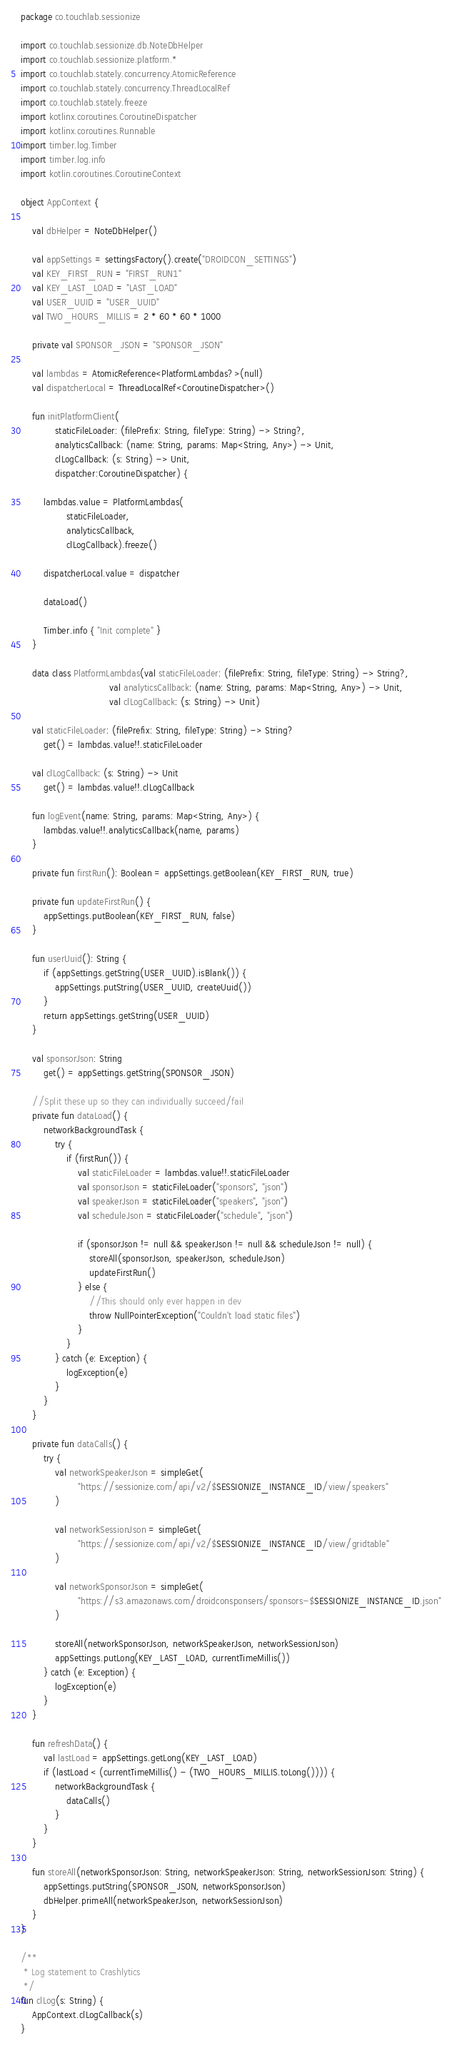Convert code to text. <code><loc_0><loc_0><loc_500><loc_500><_Kotlin_>package co.touchlab.sessionize

import co.touchlab.sessionize.db.NoteDbHelper
import co.touchlab.sessionize.platform.*
import co.touchlab.stately.concurrency.AtomicReference
import co.touchlab.stately.concurrency.ThreadLocalRef
import co.touchlab.stately.freeze
import kotlinx.coroutines.CoroutineDispatcher
import kotlinx.coroutines.Runnable
import timber.log.Timber
import timber.log.info
import kotlin.coroutines.CoroutineContext

object AppContext {

    val dbHelper = NoteDbHelper()

    val appSettings = settingsFactory().create("DROIDCON_SETTINGS")
    val KEY_FIRST_RUN = "FIRST_RUN1"
    val KEY_LAST_LOAD = "LAST_LOAD"
    val USER_UUID = "USER_UUID"
    val TWO_HOURS_MILLIS = 2 * 60 * 60 * 1000

    private val SPONSOR_JSON = "SPONSOR_JSON"

    val lambdas = AtomicReference<PlatformLambdas?>(null)
    val dispatcherLocal = ThreadLocalRef<CoroutineDispatcher>()

    fun initPlatformClient(
            staticFileLoader: (filePrefix: String, fileType: String) -> String?,
            analyticsCallback: (name: String, params: Map<String, Any>) -> Unit,
            clLogCallback: (s: String) -> Unit,
            dispatcher:CoroutineDispatcher) {

        lambdas.value = PlatformLambdas(
                staticFileLoader,
                analyticsCallback,
                clLogCallback).freeze()

        dispatcherLocal.value = dispatcher

        dataLoad()

        Timber.info { "Init complete" }
    }

    data class PlatformLambdas(val staticFileLoader: (filePrefix: String, fileType: String) -> String?,
                               val analyticsCallback: (name: String, params: Map<String, Any>) -> Unit,
                               val clLogCallback: (s: String) -> Unit)

    val staticFileLoader: (filePrefix: String, fileType: String) -> String?
        get() = lambdas.value!!.staticFileLoader

    val clLogCallback: (s: String) -> Unit
        get() = lambdas.value!!.clLogCallback

    fun logEvent(name: String, params: Map<String, Any>) {
        lambdas.value!!.analyticsCallback(name, params)
    }

    private fun firstRun(): Boolean = appSettings.getBoolean(KEY_FIRST_RUN, true)

    private fun updateFirstRun() {
        appSettings.putBoolean(KEY_FIRST_RUN, false)
    }

    fun userUuid(): String {
        if (appSettings.getString(USER_UUID).isBlank()) {
            appSettings.putString(USER_UUID, createUuid())
        }
        return appSettings.getString(USER_UUID)
    }

    val sponsorJson: String
        get() = appSettings.getString(SPONSOR_JSON)

    //Split these up so they can individually succeed/fail
    private fun dataLoad() {
        networkBackgroundTask {
            try {
                if (firstRun()) {
                    val staticFileLoader = lambdas.value!!.staticFileLoader
                    val sponsorJson = staticFileLoader("sponsors", "json")
                    val speakerJson = staticFileLoader("speakers", "json")
                    val scheduleJson = staticFileLoader("schedule", "json")

                    if (sponsorJson != null && speakerJson != null && scheduleJson != null) {
                        storeAll(sponsorJson, speakerJson, scheduleJson)
                        updateFirstRun()
                    } else {
                        //This should only ever happen in dev
                        throw NullPointerException("Couldn't load static files")
                    }
                }
            } catch (e: Exception) {
                logException(e)
            }
        }
    }

    private fun dataCalls() {
        try {
            val networkSpeakerJson = simpleGet(
                    "https://sessionize.com/api/v2/$SESSIONIZE_INSTANCE_ID/view/speakers"
            )

            val networkSessionJson = simpleGet(
                    "https://sessionize.com/api/v2/$SESSIONIZE_INSTANCE_ID/view/gridtable"
            )

            val networkSponsorJson = simpleGet(
                    "https://s3.amazonaws.com/droidconsponsers/sponsors-$SESSIONIZE_INSTANCE_ID.json"
            )

            storeAll(networkSponsorJson, networkSpeakerJson, networkSessionJson)
            appSettings.putLong(KEY_LAST_LOAD, currentTimeMillis())
        } catch (e: Exception) {
            logException(e)
        }
    }

    fun refreshData() {
        val lastLoad = appSettings.getLong(KEY_LAST_LOAD)
        if (lastLoad < (currentTimeMillis() - (TWO_HOURS_MILLIS.toLong()))) {
            networkBackgroundTask {
                dataCalls()
            }
        }
    }

    fun storeAll(networkSponsorJson: String, networkSpeakerJson: String, networkSessionJson: String) {
        appSettings.putString(SPONSOR_JSON, networkSponsorJson)
        dbHelper.primeAll(networkSpeakerJson, networkSessionJson)
    }
}

/**
 * Log statement to Crashlytics
 */
fun clLog(s: String) {
    AppContext.clLogCallback(s)
}</code> 